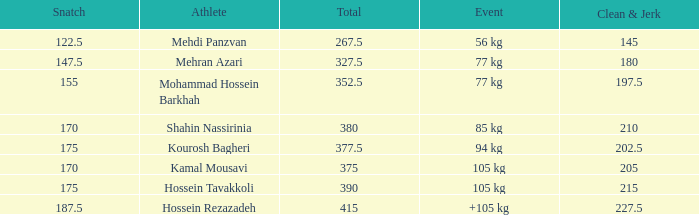Help me parse the entirety of this table. {'header': ['Snatch', 'Athlete', 'Total', 'Event', 'Clean & Jerk'], 'rows': [['122.5', 'Mehdi Panzvan', '267.5', '56 kg', '145'], ['147.5', 'Mehran Azari', '327.5', '77 kg', '180'], ['155', 'Mohammad Hossein Barkhah', '352.5', '77 kg', '197.5'], ['170', 'Shahin Nassirinia', '380', '85 kg', '210'], ['175', 'Kourosh Bagheri', '377.5', '94 kg', '202.5'], ['170', 'Kamal Mousavi', '375', '105 kg', '205'], ['175', 'Hossein Tavakkoli', '390', '105 kg', '215'], ['187.5', 'Hossein Rezazadeh', '415', '+105 kg', '227.5']]} How many snatches were there with a total of 267.5? 0.0. 